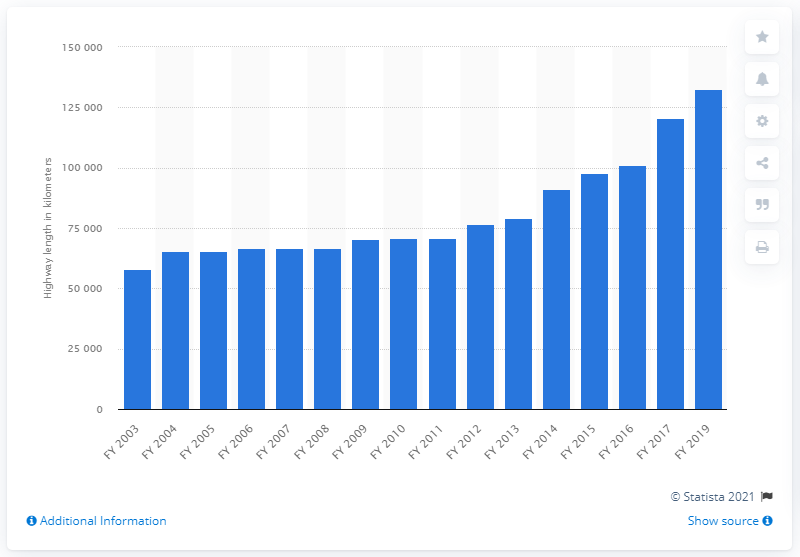Give some essential details in this illustration. In the financial year 2019, the total length of national highways in the south Asian country was 132,500 kilometers. 